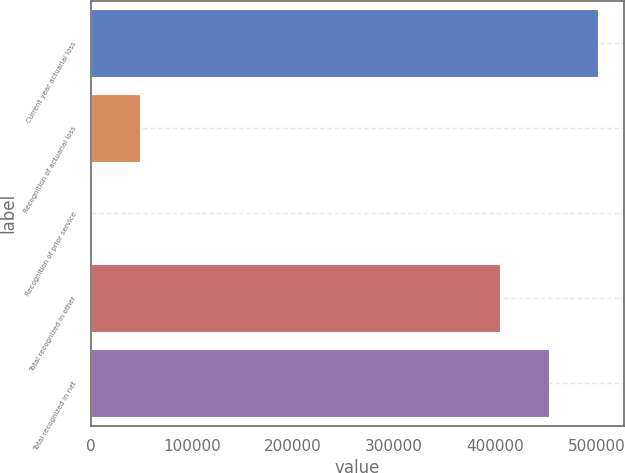Convert chart to OTSL. <chart><loc_0><loc_0><loc_500><loc_500><bar_chart><fcel>Current year actuarial loss<fcel>Recognition of actuarial loss<fcel>Recognition of prior service<fcel>Total recognized in other<fcel>Total recognized in net<nl><fcel>501769<fcel>48860<fcel>24<fcel>404097<fcel>452933<nl></chart> 